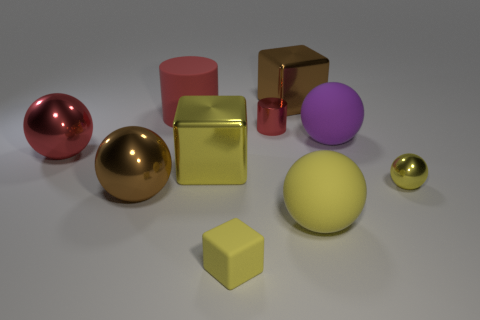Subtract all tiny yellow blocks. How many blocks are left? 2 Subtract 3 cubes. How many cubes are left? 0 Subtract all cyan blocks. How many yellow spheres are left? 2 Add 7 small rubber cubes. How many small rubber cubes are left? 8 Add 9 small blocks. How many small blocks exist? 10 Subtract all brown cubes. How many cubes are left? 2 Subtract 0 cyan cubes. How many objects are left? 10 Subtract all cylinders. How many objects are left? 8 Subtract all red balls. Subtract all red cylinders. How many balls are left? 4 Subtract all large purple matte blocks. Subtract all cubes. How many objects are left? 7 